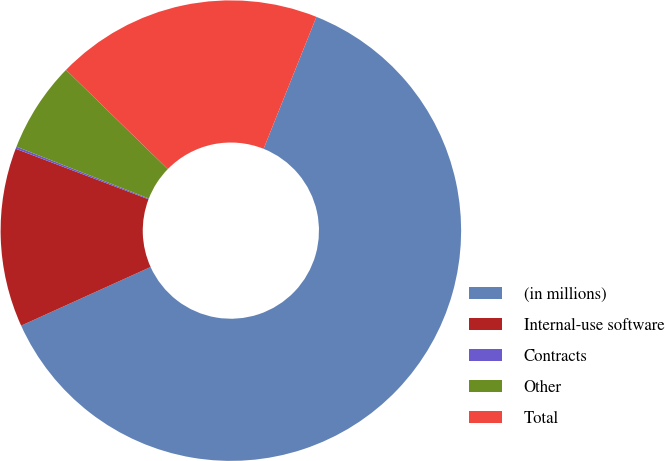Convert chart. <chart><loc_0><loc_0><loc_500><loc_500><pie_chart><fcel>(in millions)<fcel>Internal-use software<fcel>Contracts<fcel>Other<fcel>Total<nl><fcel>62.17%<fcel>12.56%<fcel>0.15%<fcel>6.36%<fcel>18.76%<nl></chart> 